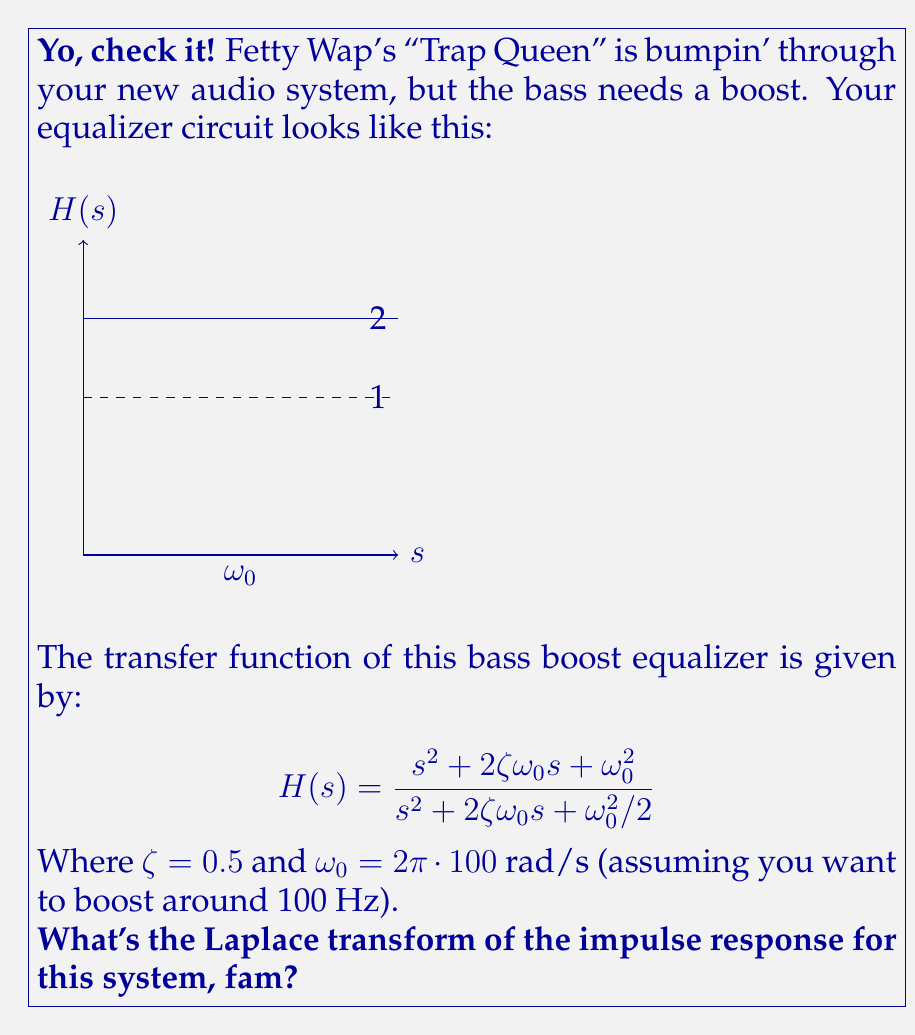What is the answer to this math problem? Aight, let's break it down step by step:

1) The Laplace transform of the impulse response is actually the transfer function itself. So we're already halfway there!

2) We just need to plug in the values we're given:
   $\zeta = 0.5$
   $\omega_0 = 2\pi \cdot 100 = 200\pi$ rad/s

3) Let's substitute these into our transfer function:

   $$ H(s) = \frac{s^2 + 2(0.5)(200\pi)s + (200\pi)^2}{s^2 + 2(0.5)(200\pi)s + (200\pi)^2/2} $$

4) Simplify:
   $$ H(s) = \frac{s^2 + 200\pi s + 40000\pi^2}{s^2 + 200\pi s + 20000\pi^2} $$

5) This is our final answer. It represents the Laplace transform of the impulse response for the bass boost equalizer.

Remember, this function will give a gain of 2 (6 dB) at the center frequency and below, boosting your bass like Fetty Wap would want!
Answer: $$ H(s) = \frac{s^2 + 200\pi s + 40000\pi^2}{s^2 + 200\pi s + 20000\pi^2} $$ 